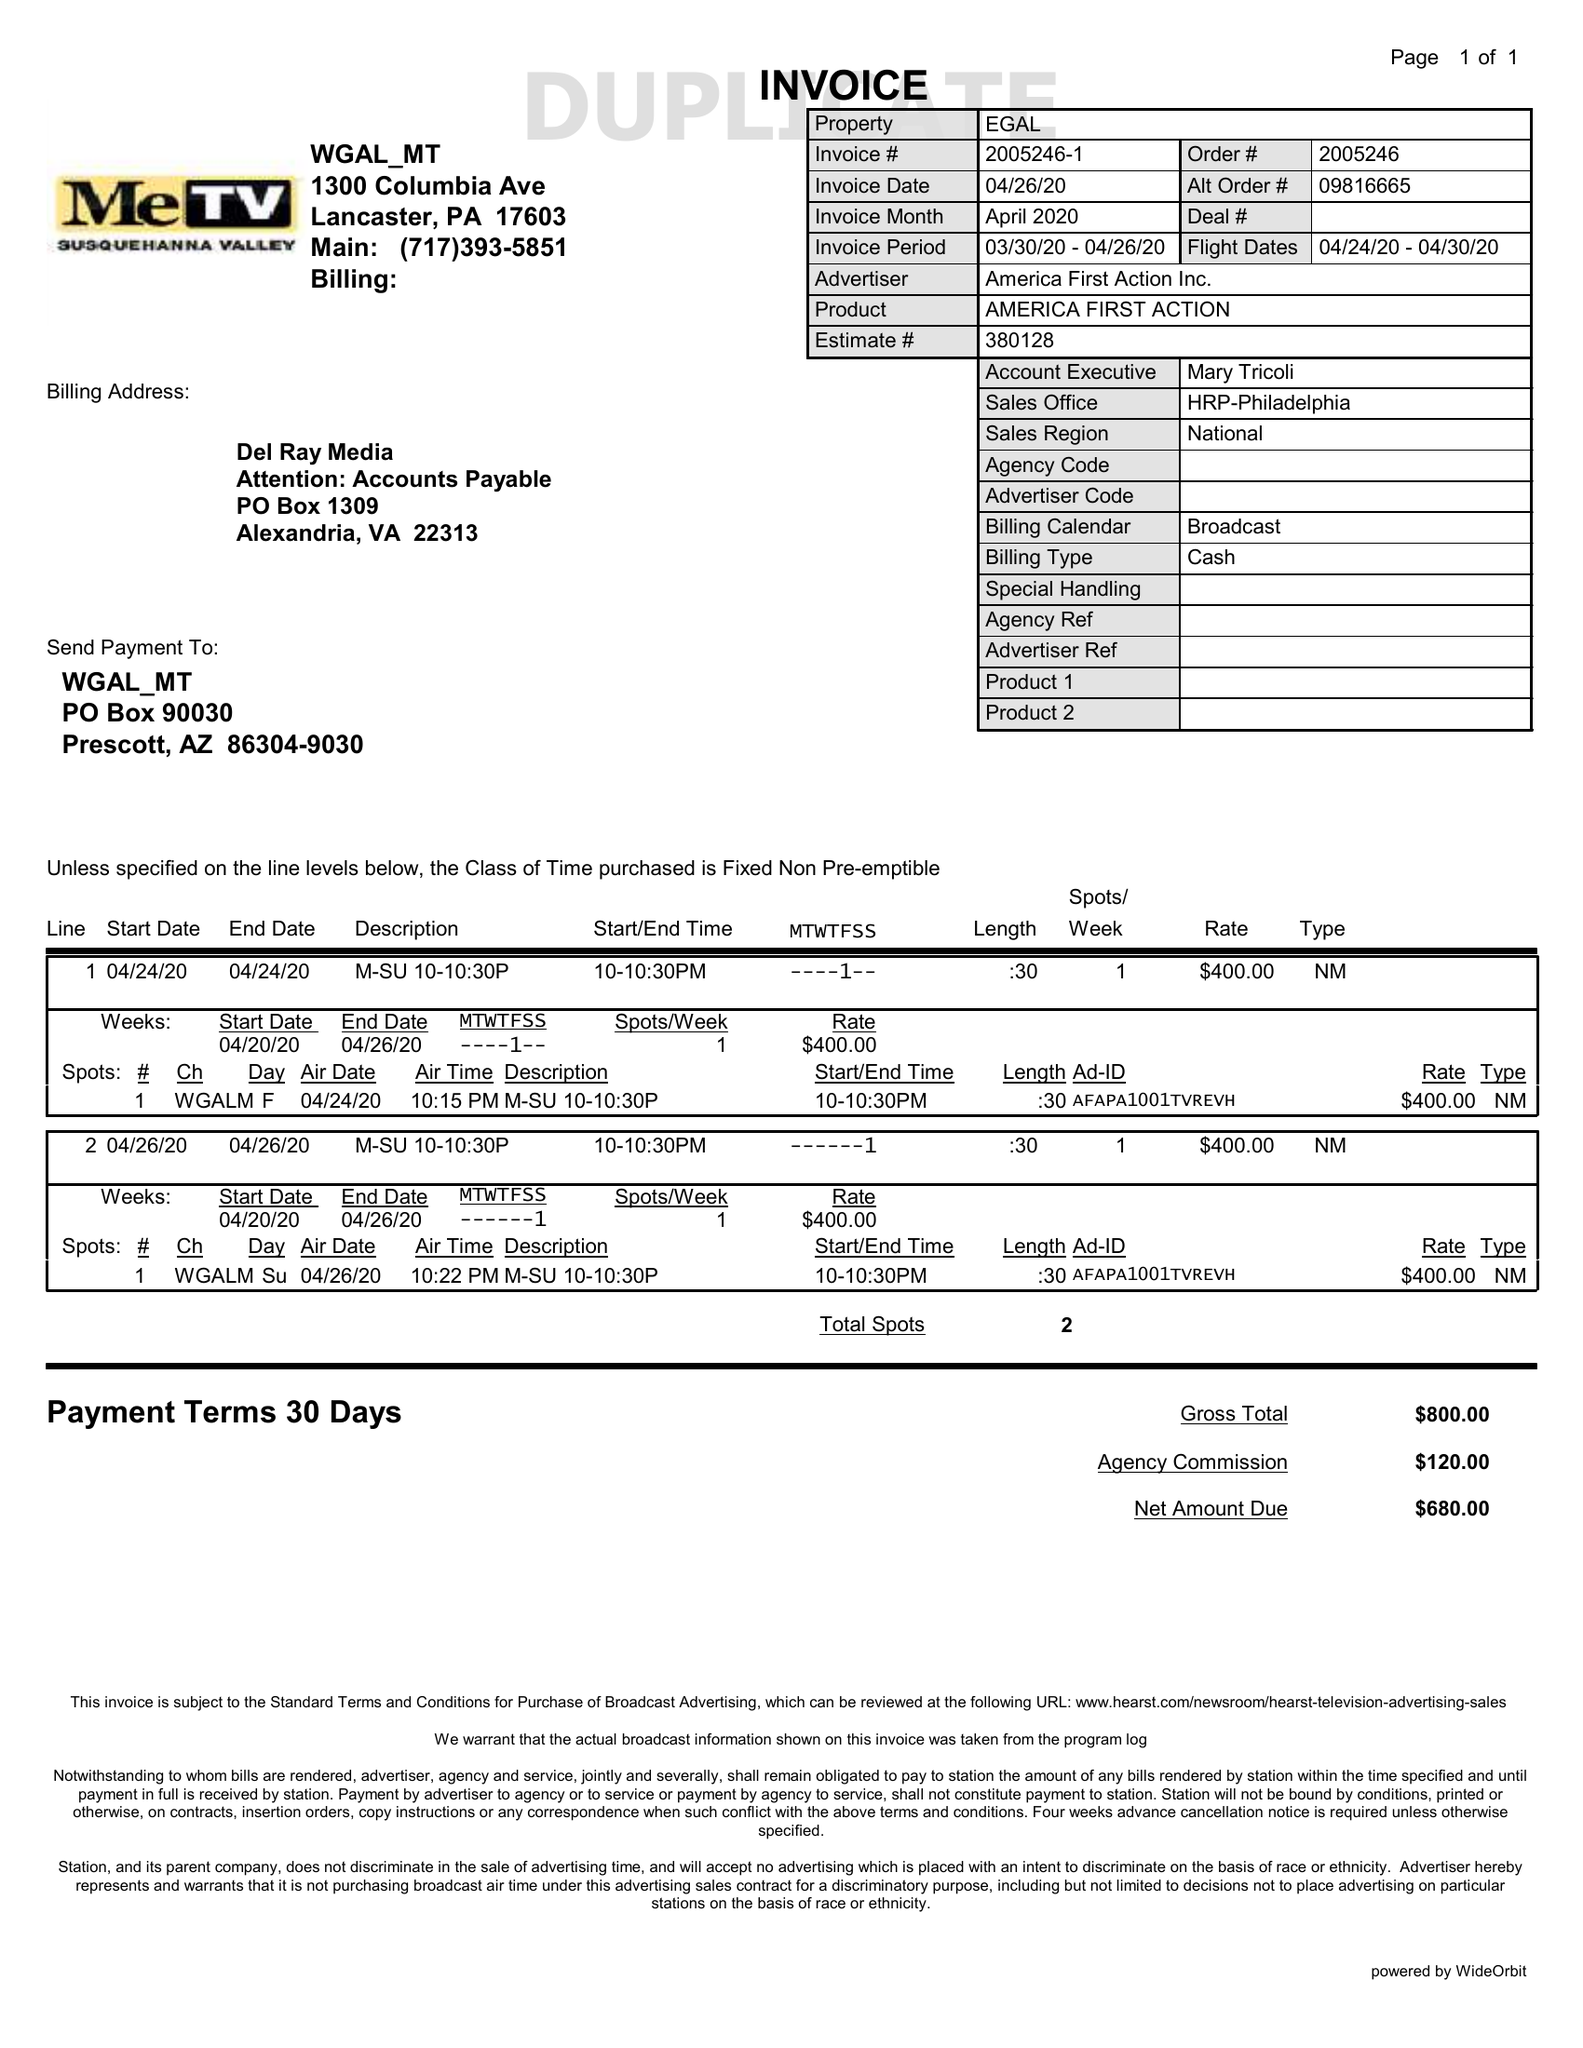What is the value for the advertiser?
Answer the question using a single word or phrase. AMERICA FIRST ACTION INC. 